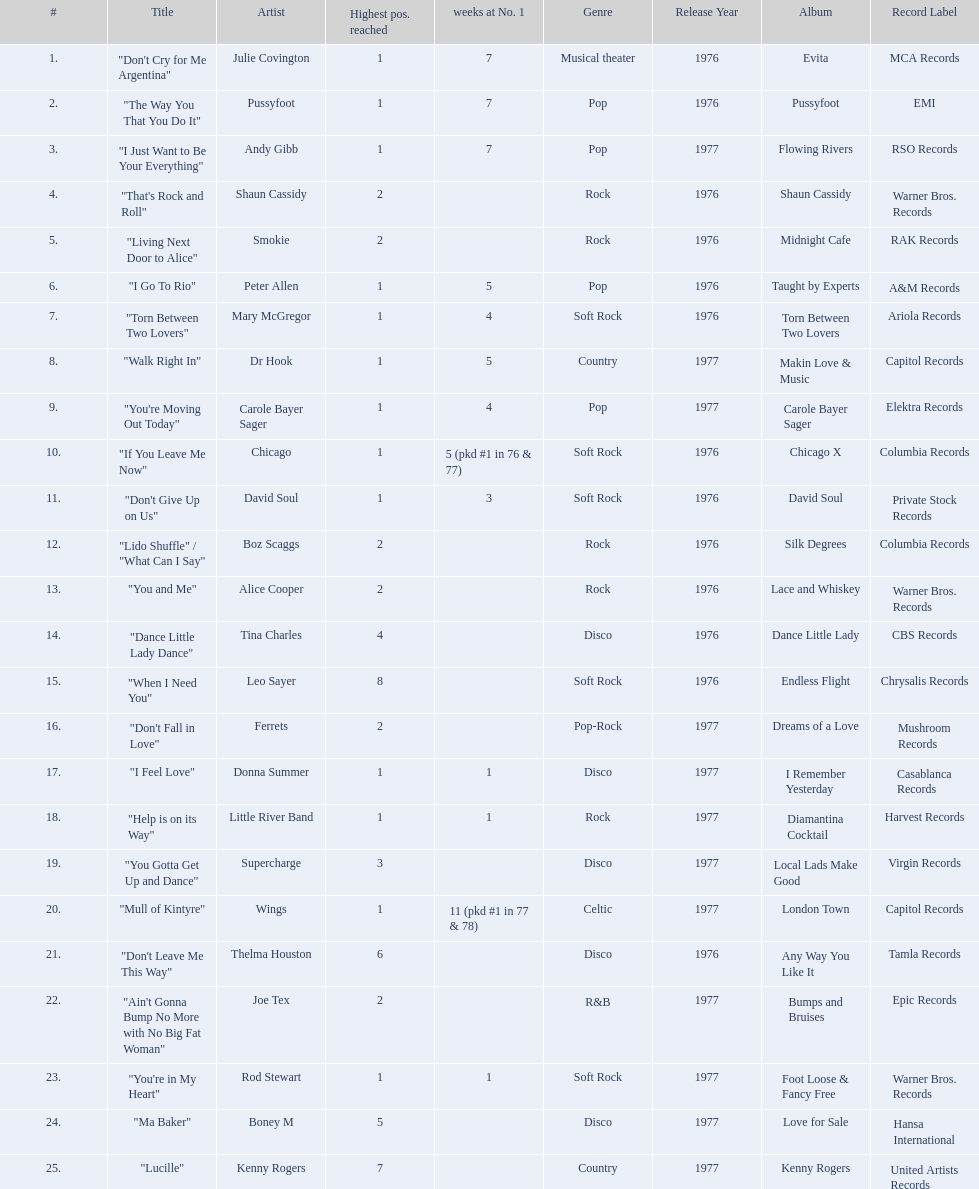Who had the one of the least weeks at number one? Rod Stewart. Who had no week at number one? Shaun Cassidy. Who had the highest number of weeks at number one? Wings. 